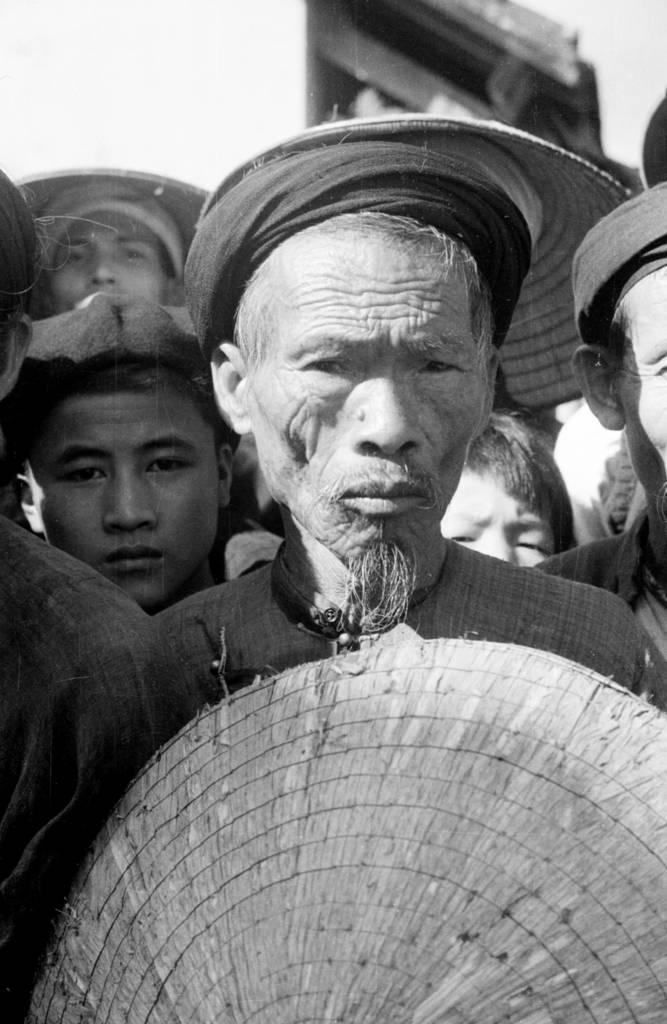What is the color scheme of the image? The image is black and white. What can be seen in the image? There are people in the image. What are the people wearing on their heads? The people are wearing hats. What is located at the bottom of the image? There is an object at the bottom of the image. What type of farm animals can be seen grazing in the image? There are no farm animals present in the image; it is a black and white image of people wearing hats. What is the zinc content of the object at the bottom of the image? There is no information about the zinc content of the object at the bottom of the image, as it is not mentioned in the provided facts. 